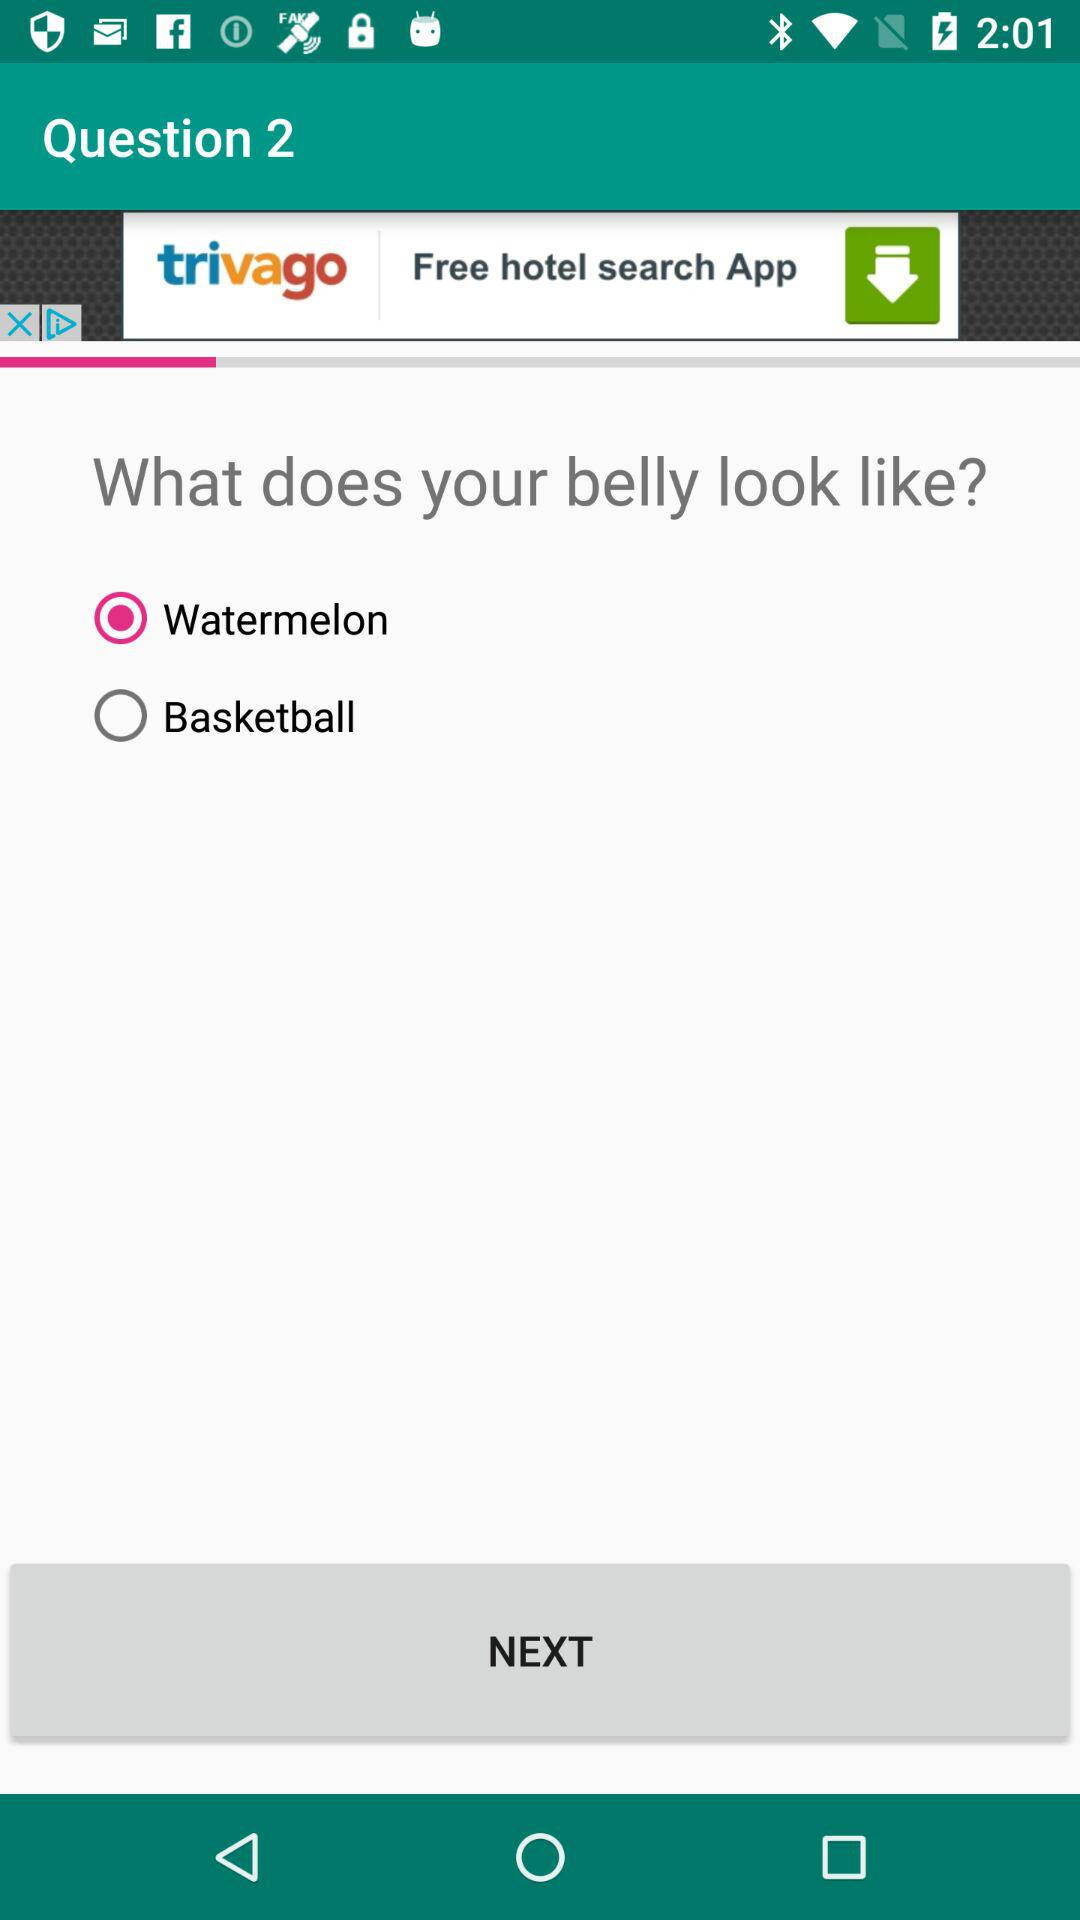What is the question number? The question number is 2. 